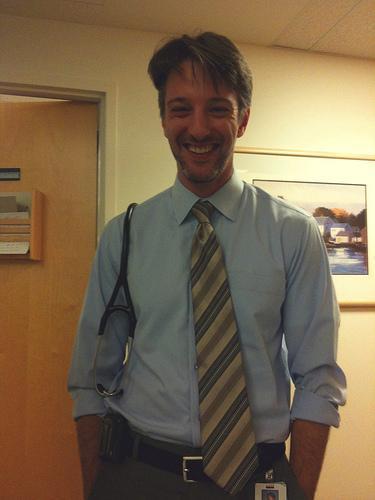How many people are there?
Give a very brief answer. 1. 